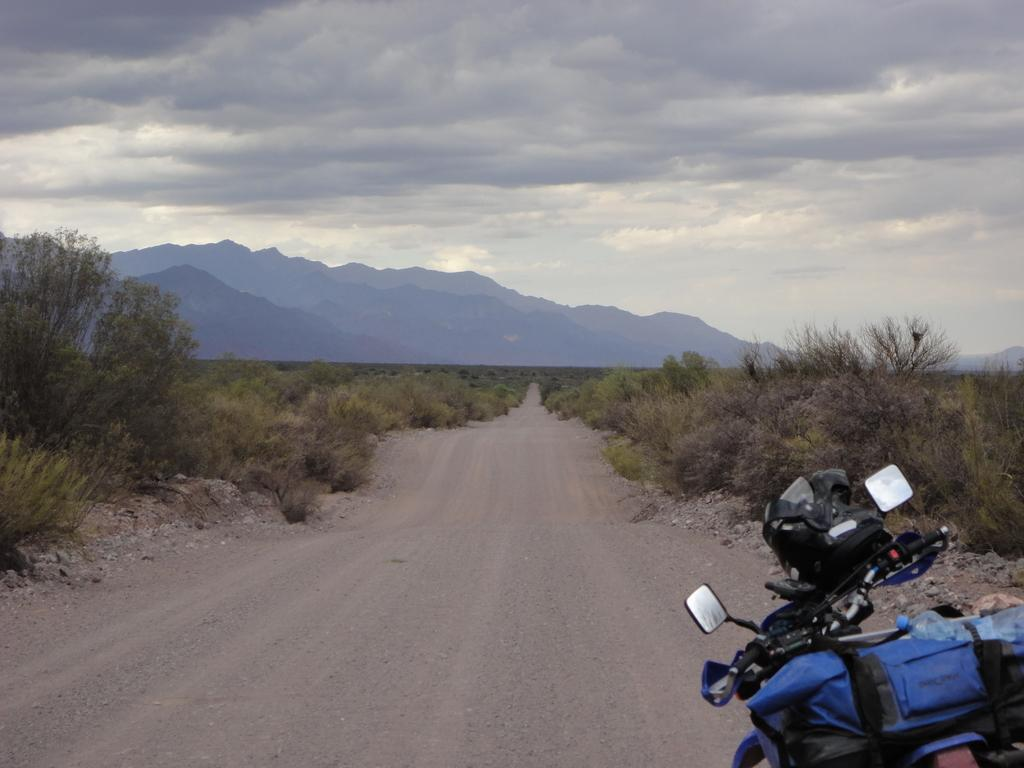What is located at the bottom of the image? There is a bike at the bottom of the image. What items are on the bike? There is a bottle and a helmet on the bike. What can be seen in the middle of the image? There are plants and trees in the middle of the image. What is visible in the background of the image? There are hills, sky, and clouds visible in the background of the image. What type of potato is being served for breakfast in the image? There is no potato or breakfast present in the image. What part of the human body is visible in the image? There are no human body parts visible in the image. 